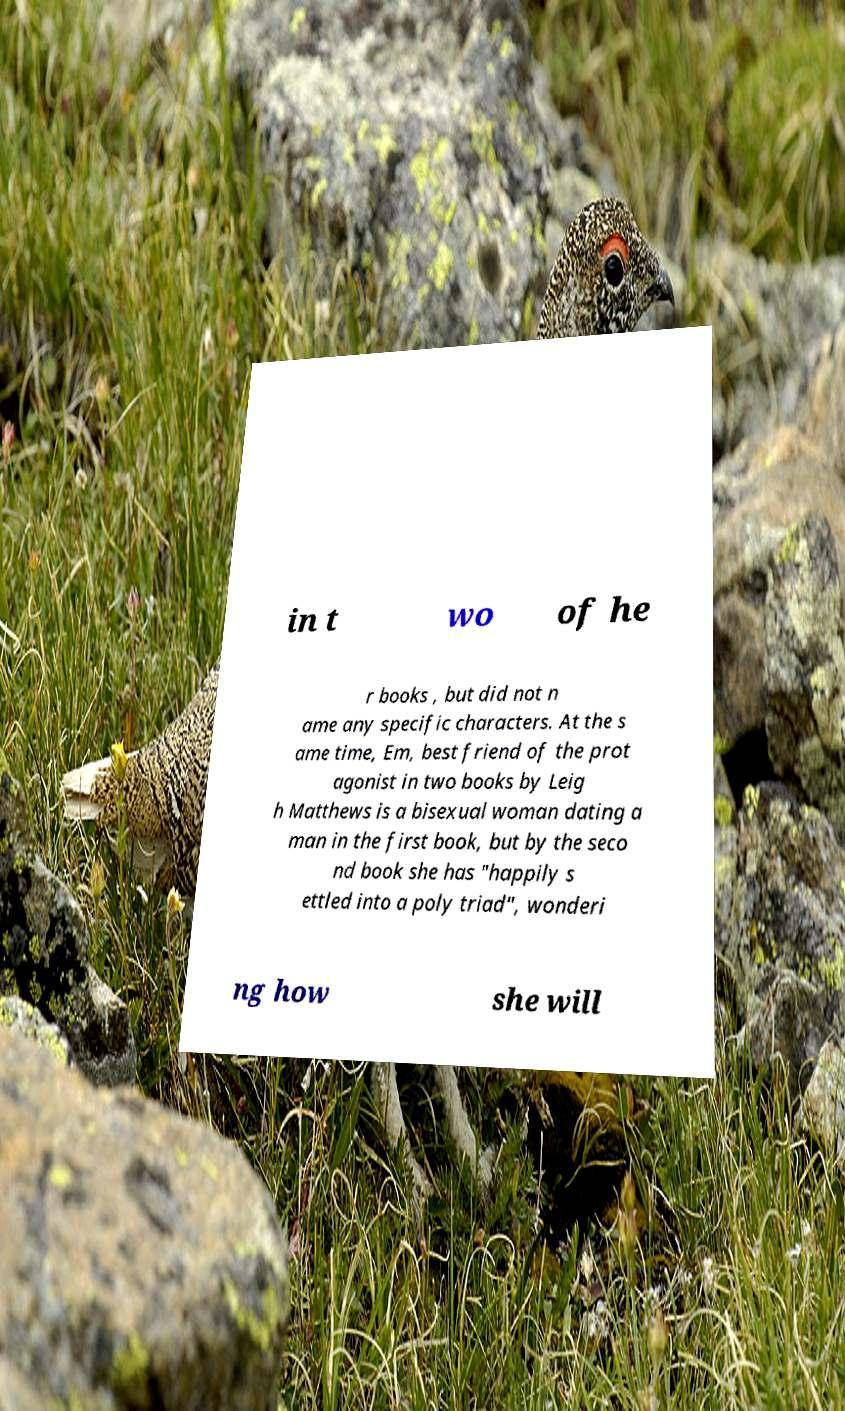Could you extract and type out the text from this image? in t wo of he r books , but did not n ame any specific characters. At the s ame time, Em, best friend of the prot agonist in two books by Leig h Matthews is a bisexual woman dating a man in the first book, but by the seco nd book she has "happily s ettled into a poly triad", wonderi ng how she will 